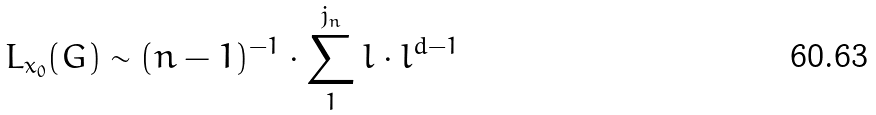<formula> <loc_0><loc_0><loc_500><loc_500>L _ { x _ { 0 } } ( G ) \sim ( n - 1 ) ^ { - 1 } \cdot \sum _ { 1 } ^ { j _ { n } } l \cdot l ^ { d - 1 }</formula> 